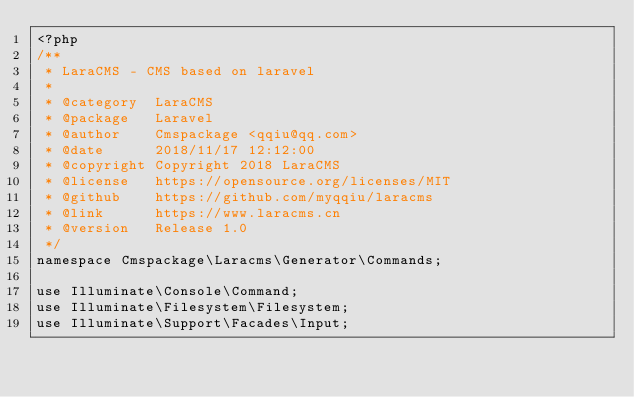Convert code to text. <code><loc_0><loc_0><loc_500><loc_500><_PHP_><?php
/**
 * LaraCMS - CMS based on laravel
 *
 * @category  LaraCMS
 * @package   Laravel
 * @author    Cmspackage <qqiu@qq.com>
 * @date      2018/11/17 12:12:00
 * @copyright Copyright 2018 LaraCMS
 * @license   https://opensource.org/licenses/MIT
 * @github    https://github.com/myqqiu/laracms
 * @link      https://www.laracms.cn
 * @version   Release 1.0
 */
namespace Cmspackage\Laracms\Generator\Commands;

use Illuminate\Console\Command;
use Illuminate\Filesystem\Filesystem;
use Illuminate\Support\Facades\Input;</code> 